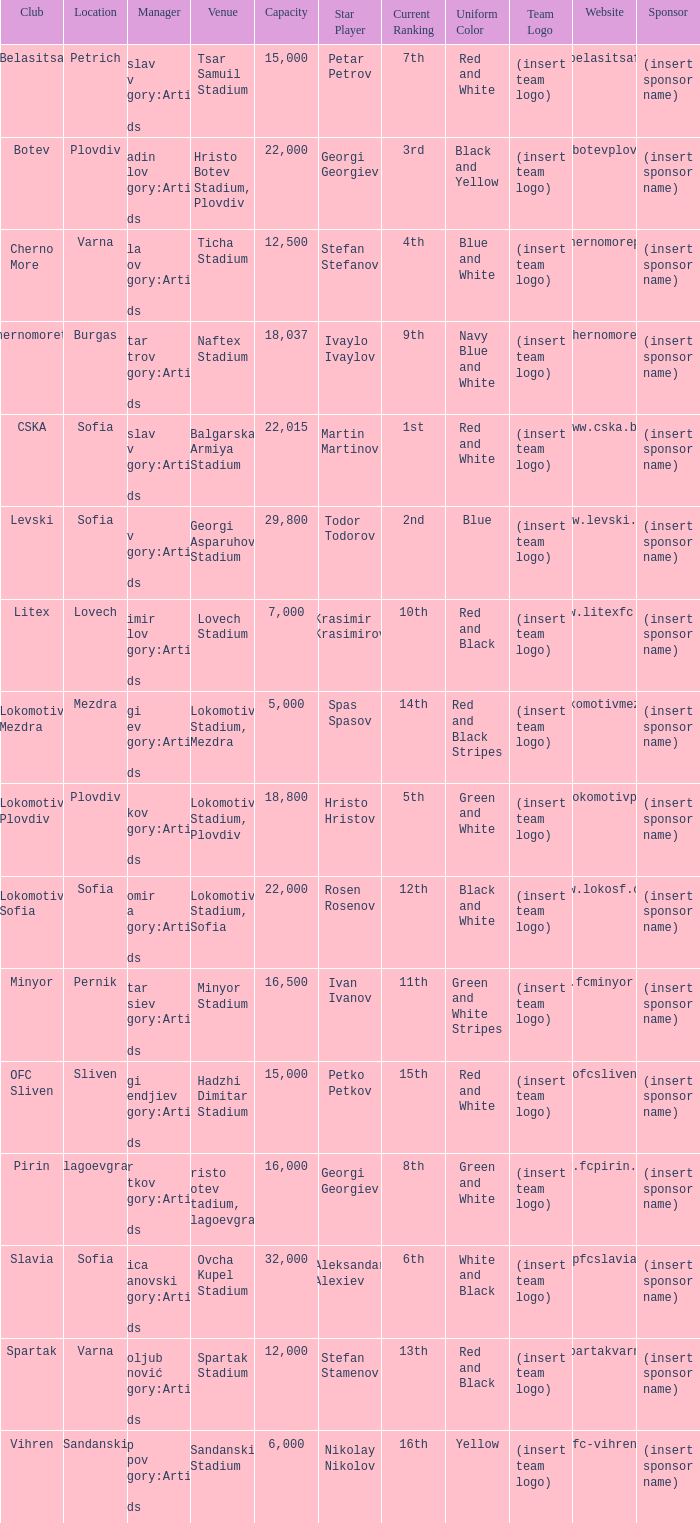What is the total number of capacity for the venue of the club, pirin? 1.0. 